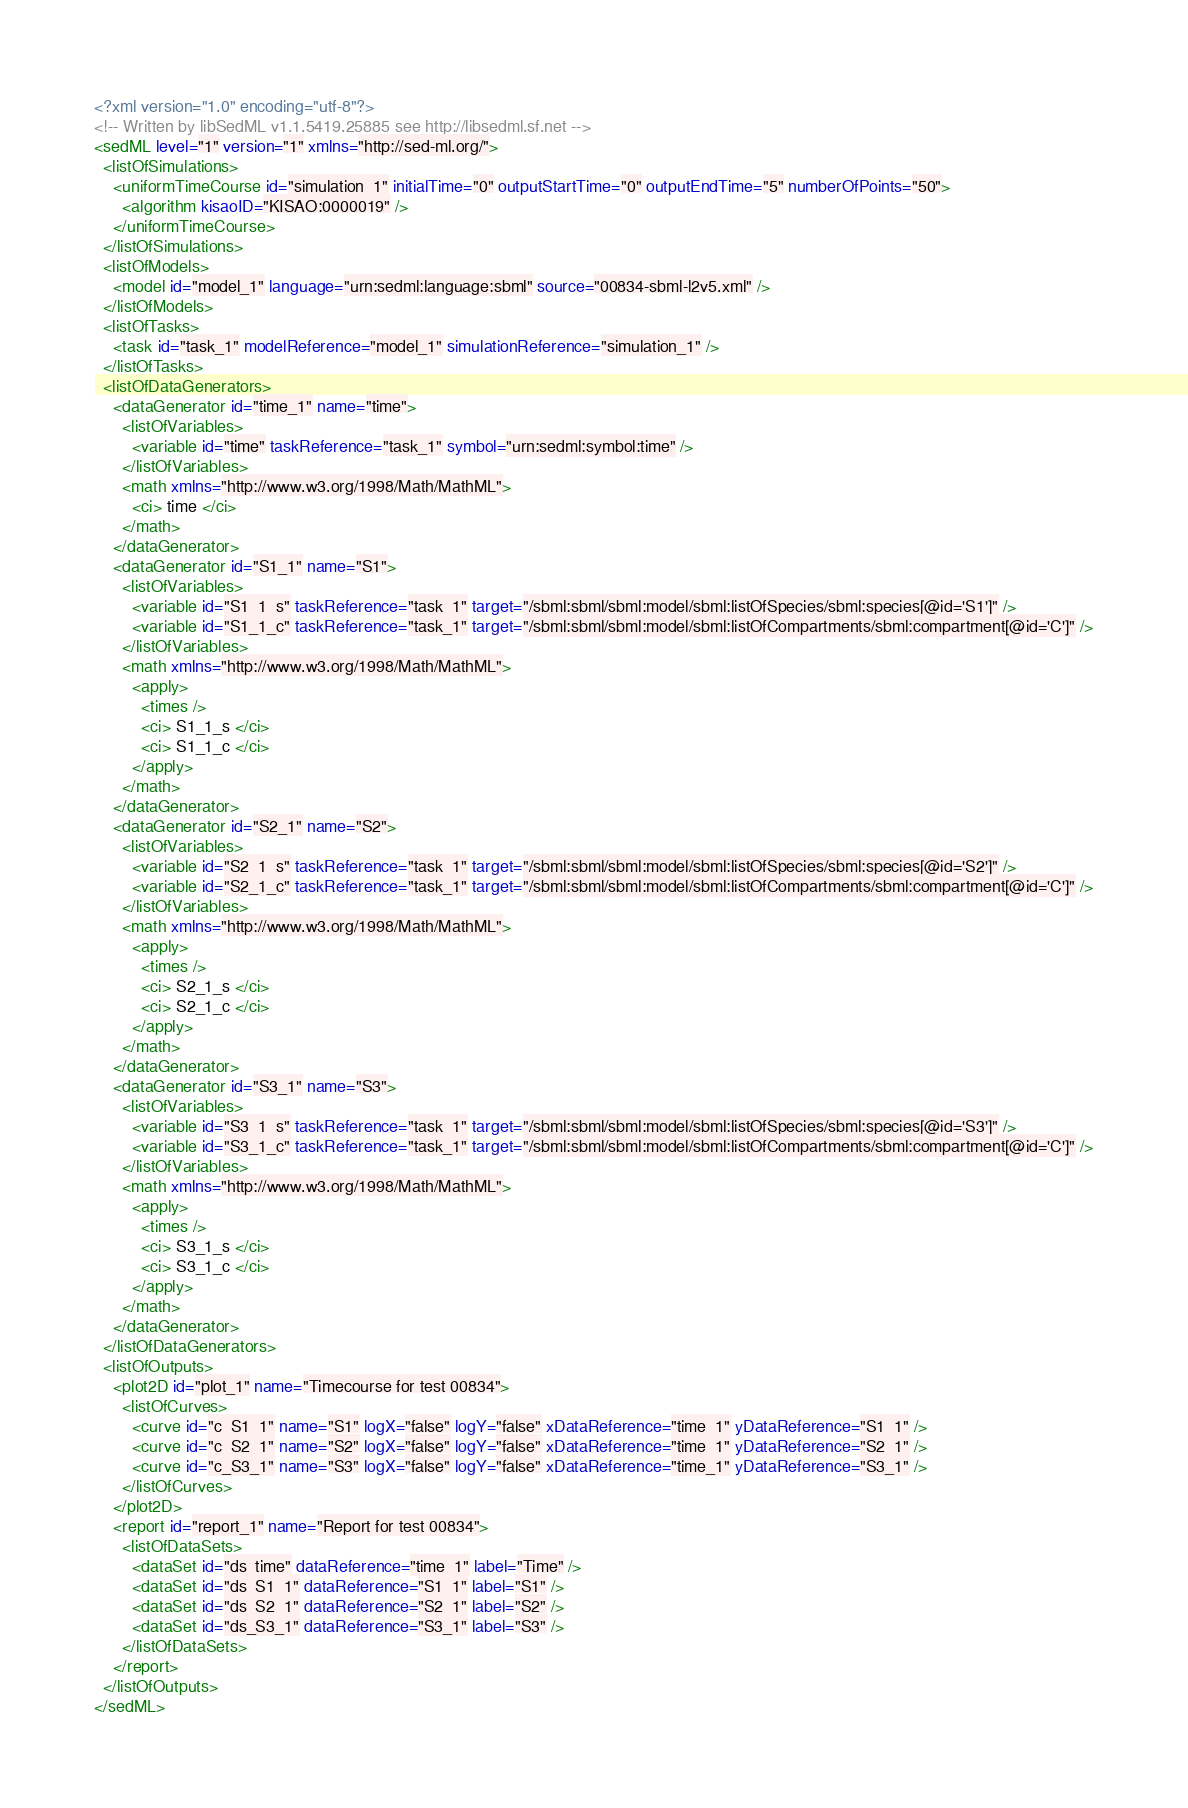<code> <loc_0><loc_0><loc_500><loc_500><_XML_><?xml version="1.0" encoding="utf-8"?>
<!-- Written by libSedML v1.1.5419.25885 see http://libsedml.sf.net -->
<sedML level="1" version="1" xmlns="http://sed-ml.org/">
  <listOfSimulations>
    <uniformTimeCourse id="simulation_1" initialTime="0" outputStartTime="0" outputEndTime="5" numberOfPoints="50">
      <algorithm kisaoID="KISAO:0000019" />
    </uniformTimeCourse>
  </listOfSimulations>
  <listOfModels>
    <model id="model_1" language="urn:sedml:language:sbml" source="00834-sbml-l2v5.xml" />
  </listOfModels>
  <listOfTasks>
    <task id="task_1" modelReference="model_1" simulationReference="simulation_1" />
  </listOfTasks>
  <listOfDataGenerators>
    <dataGenerator id="time_1" name="time">
      <listOfVariables>
        <variable id="time" taskReference="task_1" symbol="urn:sedml:symbol:time" />
      </listOfVariables>
      <math xmlns="http://www.w3.org/1998/Math/MathML">
        <ci> time </ci>
      </math>
    </dataGenerator>
    <dataGenerator id="S1_1" name="S1">
      <listOfVariables>
        <variable id="S1_1_s" taskReference="task_1" target="/sbml:sbml/sbml:model/sbml:listOfSpecies/sbml:species[@id='S1']" />
        <variable id="S1_1_c" taskReference="task_1" target="/sbml:sbml/sbml:model/sbml:listOfCompartments/sbml:compartment[@id='C']" />
      </listOfVariables>
      <math xmlns="http://www.w3.org/1998/Math/MathML">
        <apply>
          <times />
          <ci> S1_1_s </ci>
          <ci> S1_1_c </ci>
        </apply>
      </math>
    </dataGenerator>
    <dataGenerator id="S2_1" name="S2">
      <listOfVariables>
        <variable id="S2_1_s" taskReference="task_1" target="/sbml:sbml/sbml:model/sbml:listOfSpecies/sbml:species[@id='S2']" />
        <variable id="S2_1_c" taskReference="task_1" target="/sbml:sbml/sbml:model/sbml:listOfCompartments/sbml:compartment[@id='C']" />
      </listOfVariables>
      <math xmlns="http://www.w3.org/1998/Math/MathML">
        <apply>
          <times />
          <ci> S2_1_s </ci>
          <ci> S2_1_c </ci>
        </apply>
      </math>
    </dataGenerator>
    <dataGenerator id="S3_1" name="S3">
      <listOfVariables>
        <variable id="S3_1_s" taskReference="task_1" target="/sbml:sbml/sbml:model/sbml:listOfSpecies/sbml:species[@id='S3']" />
        <variable id="S3_1_c" taskReference="task_1" target="/sbml:sbml/sbml:model/sbml:listOfCompartments/sbml:compartment[@id='C']" />
      </listOfVariables>
      <math xmlns="http://www.w3.org/1998/Math/MathML">
        <apply>
          <times />
          <ci> S3_1_s </ci>
          <ci> S3_1_c </ci>
        </apply>
      </math>
    </dataGenerator>
  </listOfDataGenerators>
  <listOfOutputs>
    <plot2D id="plot_1" name="Timecourse for test 00834">
      <listOfCurves>
        <curve id="c_S1_1" name="S1" logX="false" logY="false" xDataReference="time_1" yDataReference="S1_1" />
        <curve id="c_S2_1" name="S2" logX="false" logY="false" xDataReference="time_1" yDataReference="S2_1" />
        <curve id="c_S3_1" name="S3" logX="false" logY="false" xDataReference="time_1" yDataReference="S3_1" />
      </listOfCurves>
    </plot2D>
    <report id="report_1" name="Report for test 00834">
      <listOfDataSets>
        <dataSet id="ds_time" dataReference="time_1" label="Time" />
        <dataSet id="ds_S1_1" dataReference="S1_1" label="S1" />
        <dataSet id="ds_S2_1" dataReference="S2_1" label="S2" />
        <dataSet id="ds_S3_1" dataReference="S3_1" label="S3" />
      </listOfDataSets>
    </report>
  </listOfOutputs>
</sedML></code> 